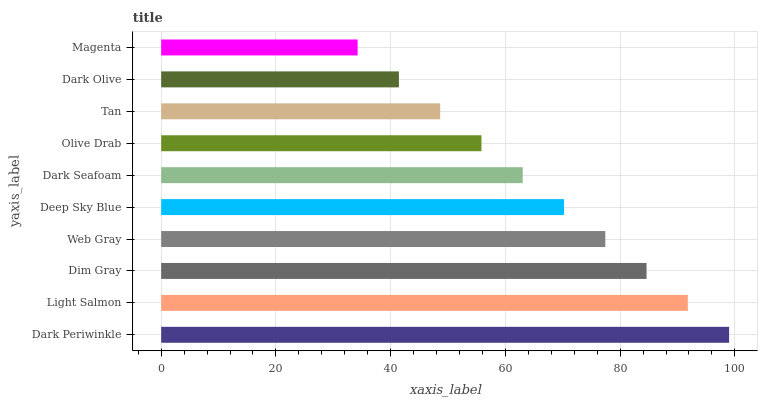Is Magenta the minimum?
Answer yes or no. Yes. Is Dark Periwinkle the maximum?
Answer yes or no. Yes. Is Light Salmon the minimum?
Answer yes or no. No. Is Light Salmon the maximum?
Answer yes or no. No. Is Dark Periwinkle greater than Light Salmon?
Answer yes or no. Yes. Is Light Salmon less than Dark Periwinkle?
Answer yes or no. Yes. Is Light Salmon greater than Dark Periwinkle?
Answer yes or no. No. Is Dark Periwinkle less than Light Salmon?
Answer yes or no. No. Is Deep Sky Blue the high median?
Answer yes or no. Yes. Is Dark Seafoam the low median?
Answer yes or no. Yes. Is Tan the high median?
Answer yes or no. No. Is Dark Olive the low median?
Answer yes or no. No. 